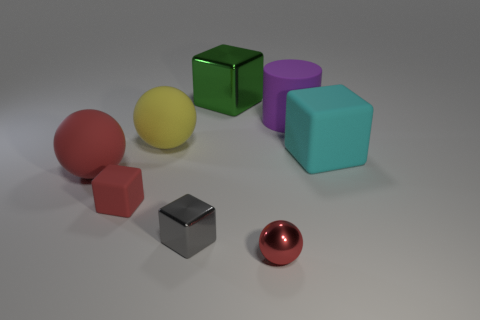Subtract 1 cubes. How many cubes are left? 3 Add 2 purple matte cubes. How many objects exist? 10 Subtract all balls. How many objects are left? 5 Subtract 0 red cylinders. How many objects are left? 8 Subtract all large purple rubber cylinders. Subtract all yellow balls. How many objects are left? 6 Add 3 tiny gray things. How many tiny gray things are left? 4 Add 5 small gray metallic cylinders. How many small gray metallic cylinders exist? 5 